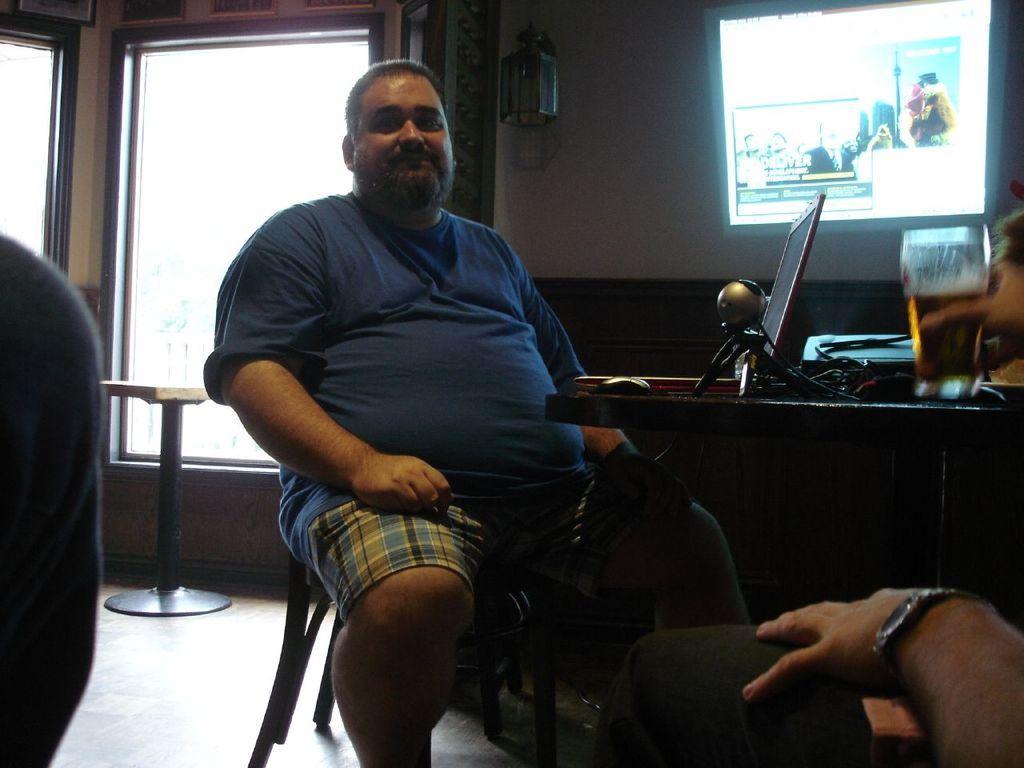In one or two sentences, can you explain what this image depicts? In the picture there is a man sitting in front of the table and on the table there is a laptop , some wires and other objects. In front of him there are two other people and in the background there is a wall and in front of the wall there is a screen that is displaying something, on the left side there is a window and there is another table in front of the window. 